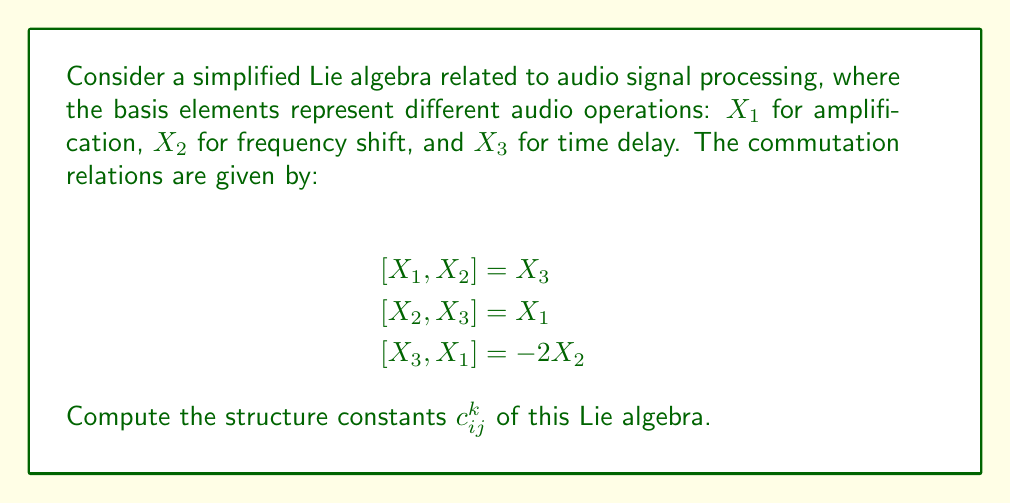Help me with this question. To find the structure constants of this Lie algebra, we need to express the commutation relations in terms of the structure constants. The general form of a commutation relation is:

$$[X_i, X_j] = \sum_{k=1}^3 c_{ij}^k X_k$$

where $c_{ij}^k$ are the structure constants.

Let's analyze each commutation relation:

1) $[X_1, X_2] = X_3$
   This implies $c_{12}^3 = 1$, and all other $c_{12}^k = 0$

2) $[X_2, X_3] = X_1$
   This implies $c_{23}^1 = 1$, and all other $c_{23}^k = 0$

3) $[X_3, X_1] = -2X_2$
   This implies $c_{31}^2 = -2$, and all other $c_{31}^k = 0$

Note that the structure constants are antisymmetric in the lower indices, meaning:
$$c_{ij}^k = -c_{ji}^k$$

So, we can also deduce:
$c_{21}^3 = -1$
$c_{32}^1 = -1$
$c_{13}^2 = 2$

All other structure constants are zero.
Answer: The non-zero structure constants are:

$c_{12}^3 = 1$, $c_{21}^3 = -1$
$c_{23}^1 = 1$, $c_{32}^1 = -1$
$c_{31}^2 = -2$, $c_{13}^2 = 2$

All other $c_{ij}^k = 0$ 